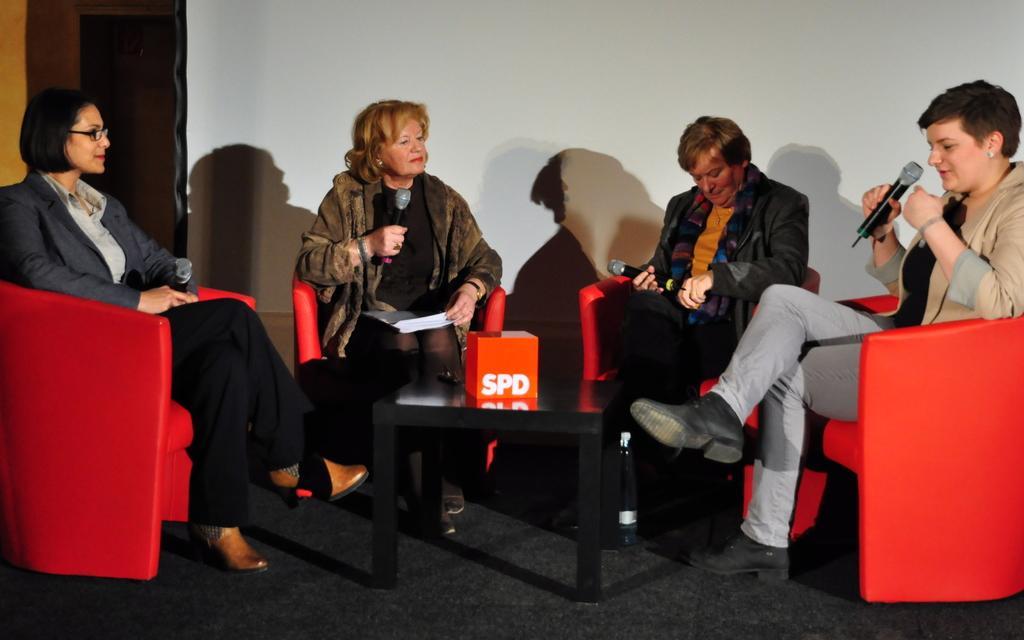Describe this image in one or two sentences. There are four women sitting on red chairs. Every woman is holding mike on their hands. There is a small table with orange color object placed on it. 